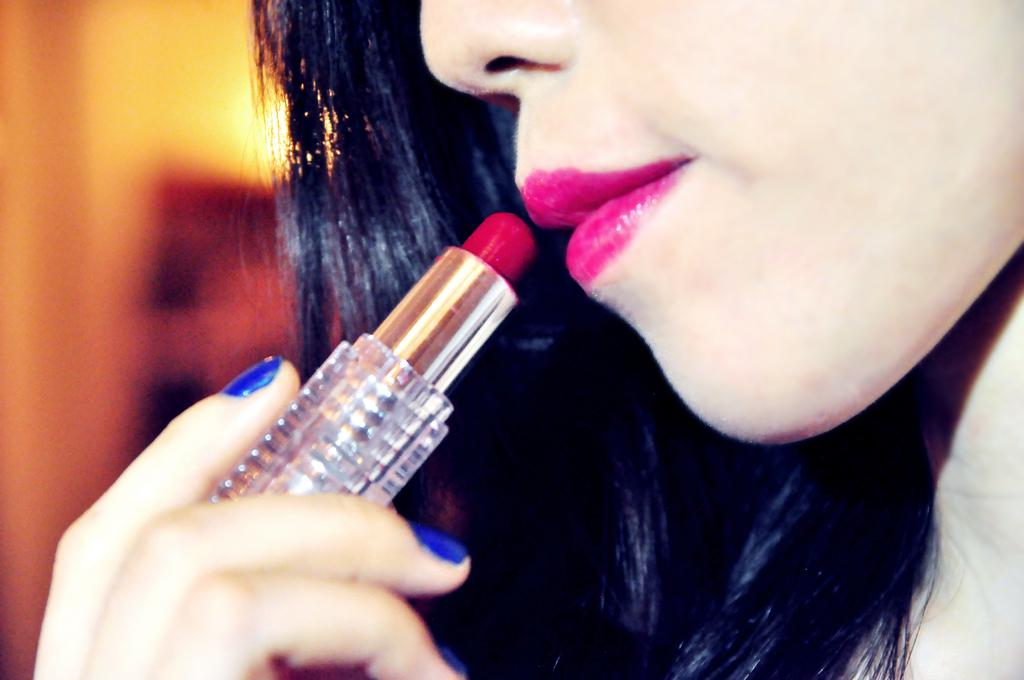Who is present in the image? There is a woman in the image. What is the woman holding in the image? The woman is holding lipstick. What can be seen in the image besides the woman and the lipstick? There is a light visible in the image. How would you describe the background of the image? The background of the image is blurred. What type of glass is the woman drinking from in the image? There is no glass present in the image; the woman is holding lipstick. 